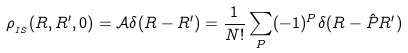<formula> <loc_0><loc_0><loc_500><loc_500>\rho _ { _ { I S } } ( R , R ^ { \prime } , 0 ) = \mathcal { A } \delta ( R - R ^ { \prime } ) = \frac { 1 } { N ! } \sum _ { P } ( - 1 ) ^ { P } \delta ( R - \hat { P } R ^ { \prime } )</formula> 